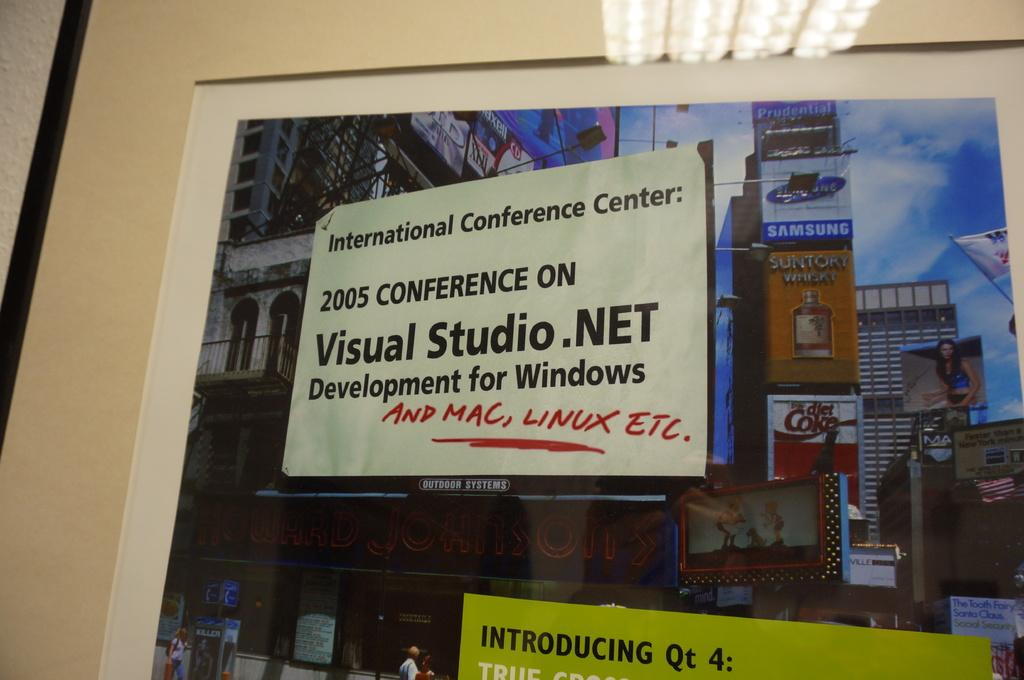<image>
Write a terse but informative summary of the picture. A poster of Times Square advertising a visual studios development conference in 2005. 